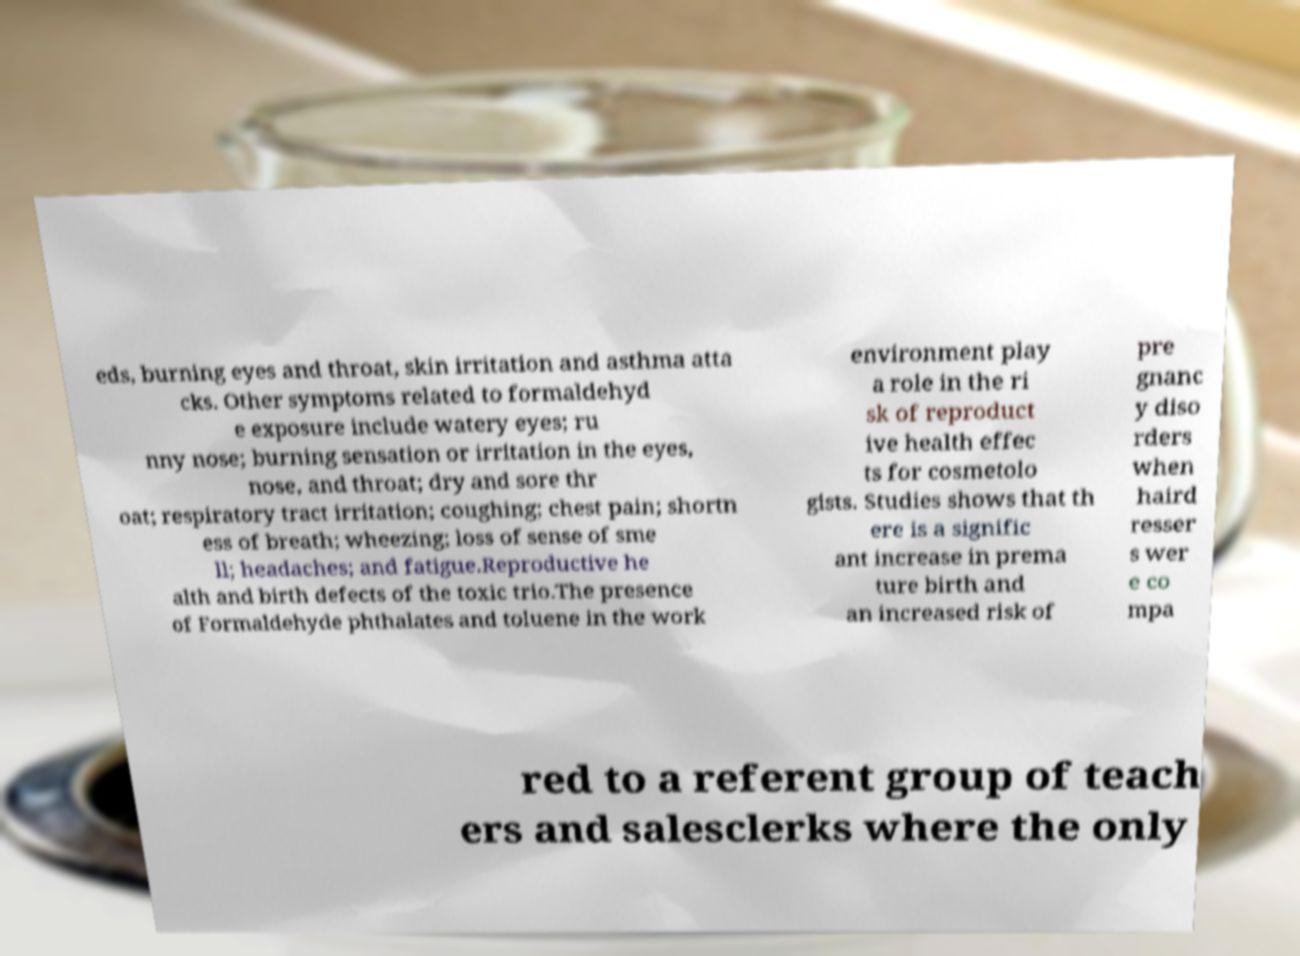Please read and relay the text visible in this image. What does it say? eds, burning eyes and throat, skin irritation and asthma atta cks. Other symptoms related to formaldehyd e exposure include watery eyes; ru nny nose; burning sensation or irritation in the eyes, nose, and throat; dry and sore thr oat; respiratory tract irritation; coughing; chest pain; shortn ess of breath; wheezing; loss of sense of sme ll; headaches; and fatigue.Reproductive he alth and birth defects of the toxic trio.The presence of Formaldehyde phthalates and toluene in the work environment play a role in the ri sk of reproduct ive health effec ts for cosmetolo gists. Studies shows that th ere is a signific ant increase in prema ture birth and an increased risk of pre gnanc y diso rders when haird resser s wer e co mpa red to a referent group of teach ers and salesclerks where the only 